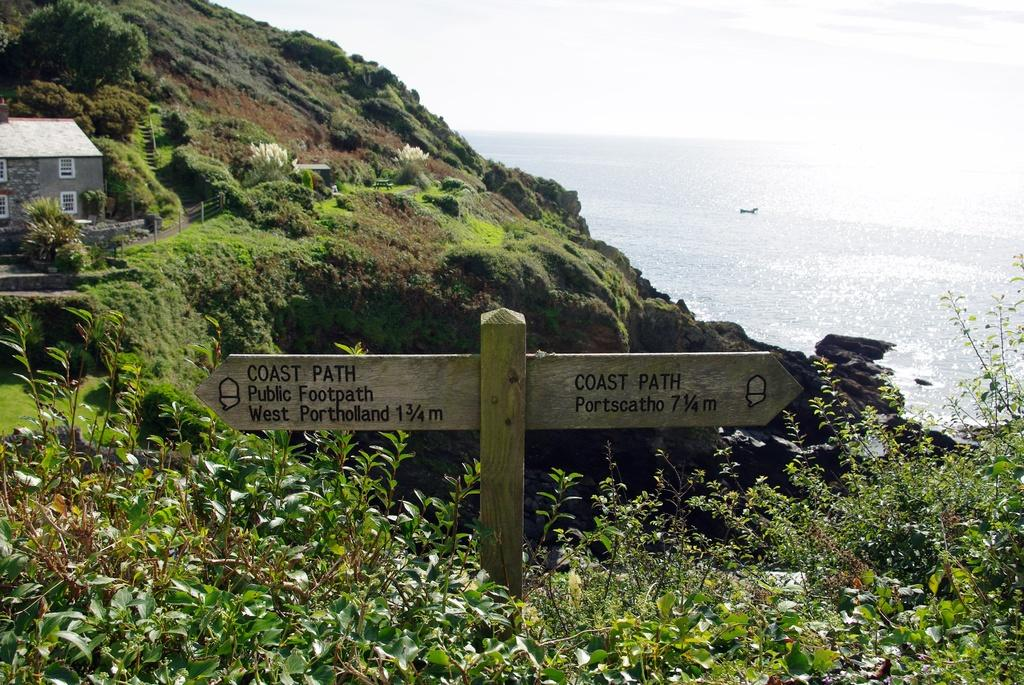What is attached to the wooden pole in the image? There are boards attached to a wooden pole in the image. What type of living organisms can be seen in the image? Plants are visible in the image. What can be seen in the background of the image? There is a house, more plants, trees, water, and the sky visible in the background of the image. What type of bed can be seen in the image? There is no bed present in the image. How does the car move around in the image? There is no car present in the image; it cannot be moved around. 